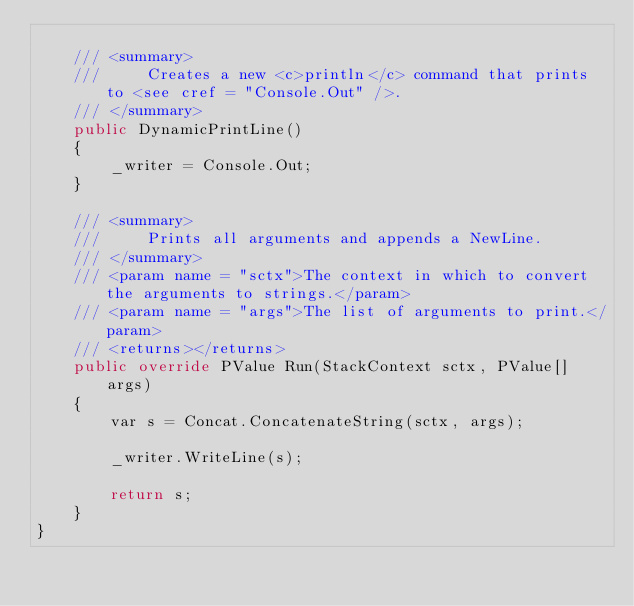<code> <loc_0><loc_0><loc_500><loc_500><_C#_>
    /// <summary>
    ///     Creates a new <c>println</c> command that prints to <see cref = "Console.Out" />.
    /// </summary>
    public DynamicPrintLine()
    {
        _writer = Console.Out;
    }

    /// <summary>
    ///     Prints all arguments and appends a NewLine.
    /// </summary>
    /// <param name = "sctx">The context in which to convert the arguments to strings.</param>
    /// <param name = "args">The list of arguments to print.</param>
    /// <returns></returns>
    public override PValue Run(StackContext sctx, PValue[] args)
    {
        var s = Concat.ConcatenateString(sctx, args);

        _writer.WriteLine(s);

        return s;
    }
}</code> 